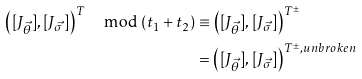<formula> <loc_0><loc_0><loc_500><loc_500>\left ( [ J _ { \vec { \theta } } ] , [ J _ { \vec { \sigma } } ] \right ) ^ { T } \mod ( t _ { 1 } + t _ { 2 } ) & \equiv \left ( [ J _ { \vec { \theta } } ] , [ J _ { \vec { \sigma } } ] \right ) ^ { T ^ { \pm } } \\ & = \left ( [ J _ { \vec { \theta } } ] , [ J _ { \vec { \sigma } } ] \right ) ^ { T ^ { \pm } , u n b r o k e n }</formula> 